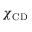Convert formula to latex. <formula><loc_0><loc_0><loc_500><loc_500>\chi _ { C D }</formula> 